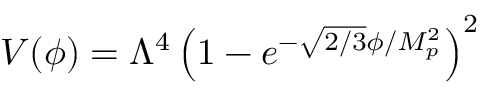<formula> <loc_0><loc_0><loc_500><loc_500>V ( \phi ) = \Lambda ^ { 4 } \left ( 1 - e ^ { - { \sqrt { 2 / 3 } } \phi / M _ { p } ^ { 2 } } \right ) ^ { 2 }</formula> 